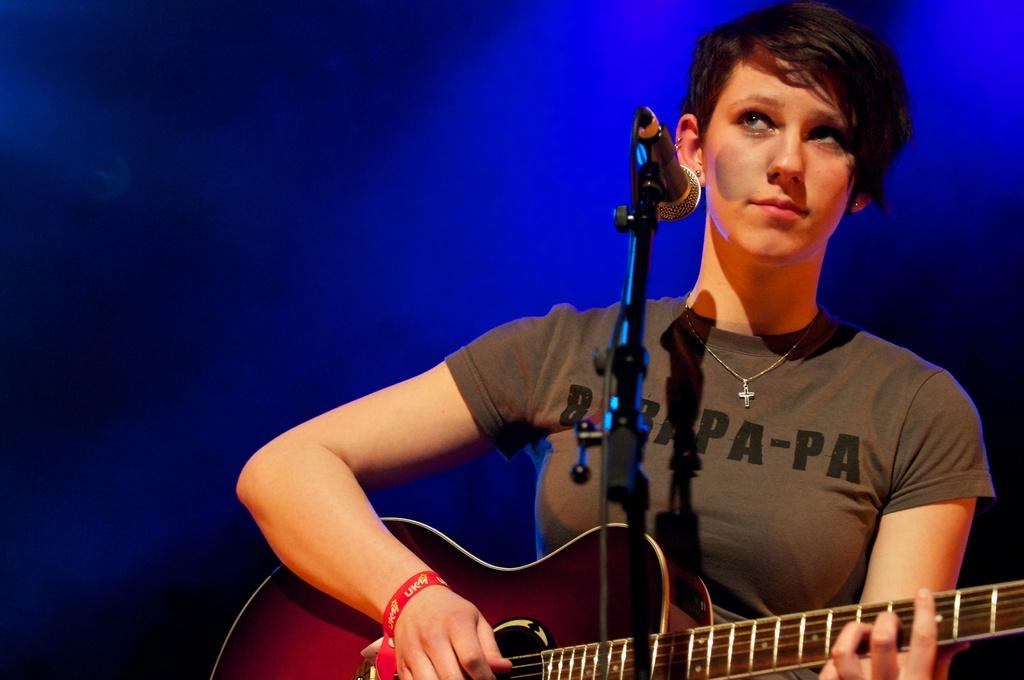Who is the main subject in the image? There is a woman in the image. What is the woman doing in the image? The woman is in front of a mic and holding a guitar. What type of feather can be seen on the woman's hat in the image? There is no hat or feather present in the image. What is the woman using the oven for in the image? There is no oven present in the image. 